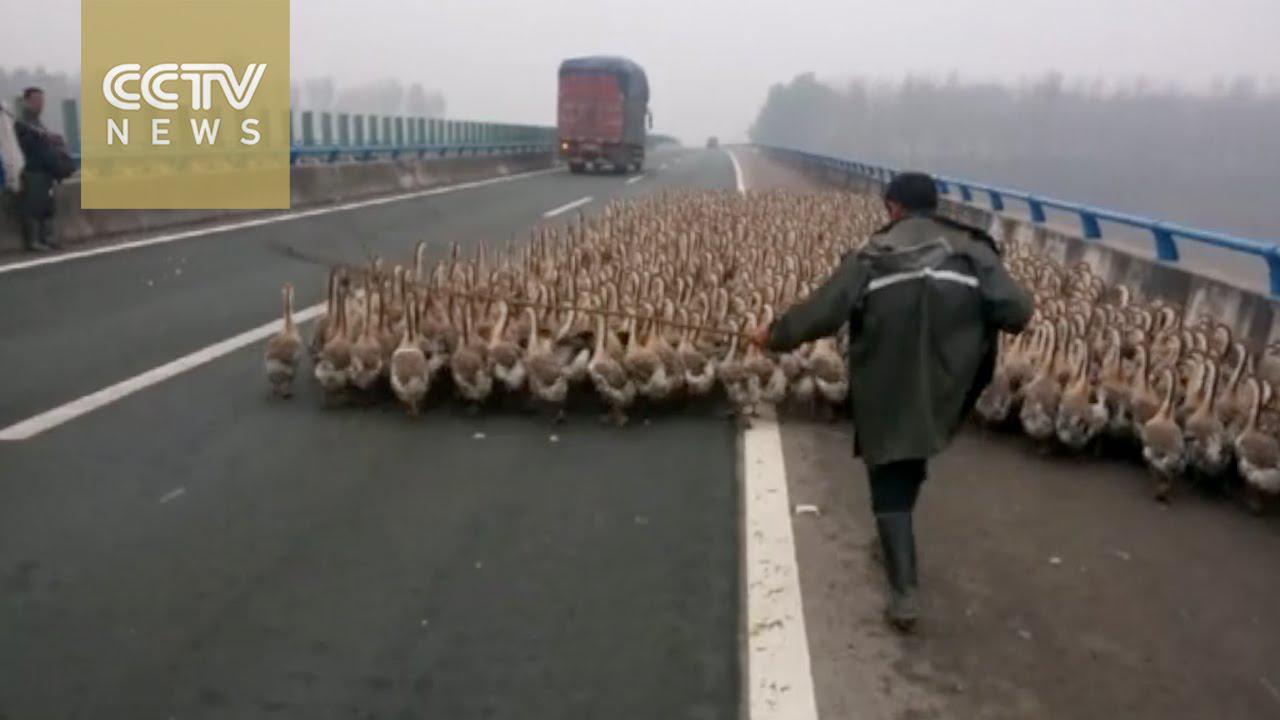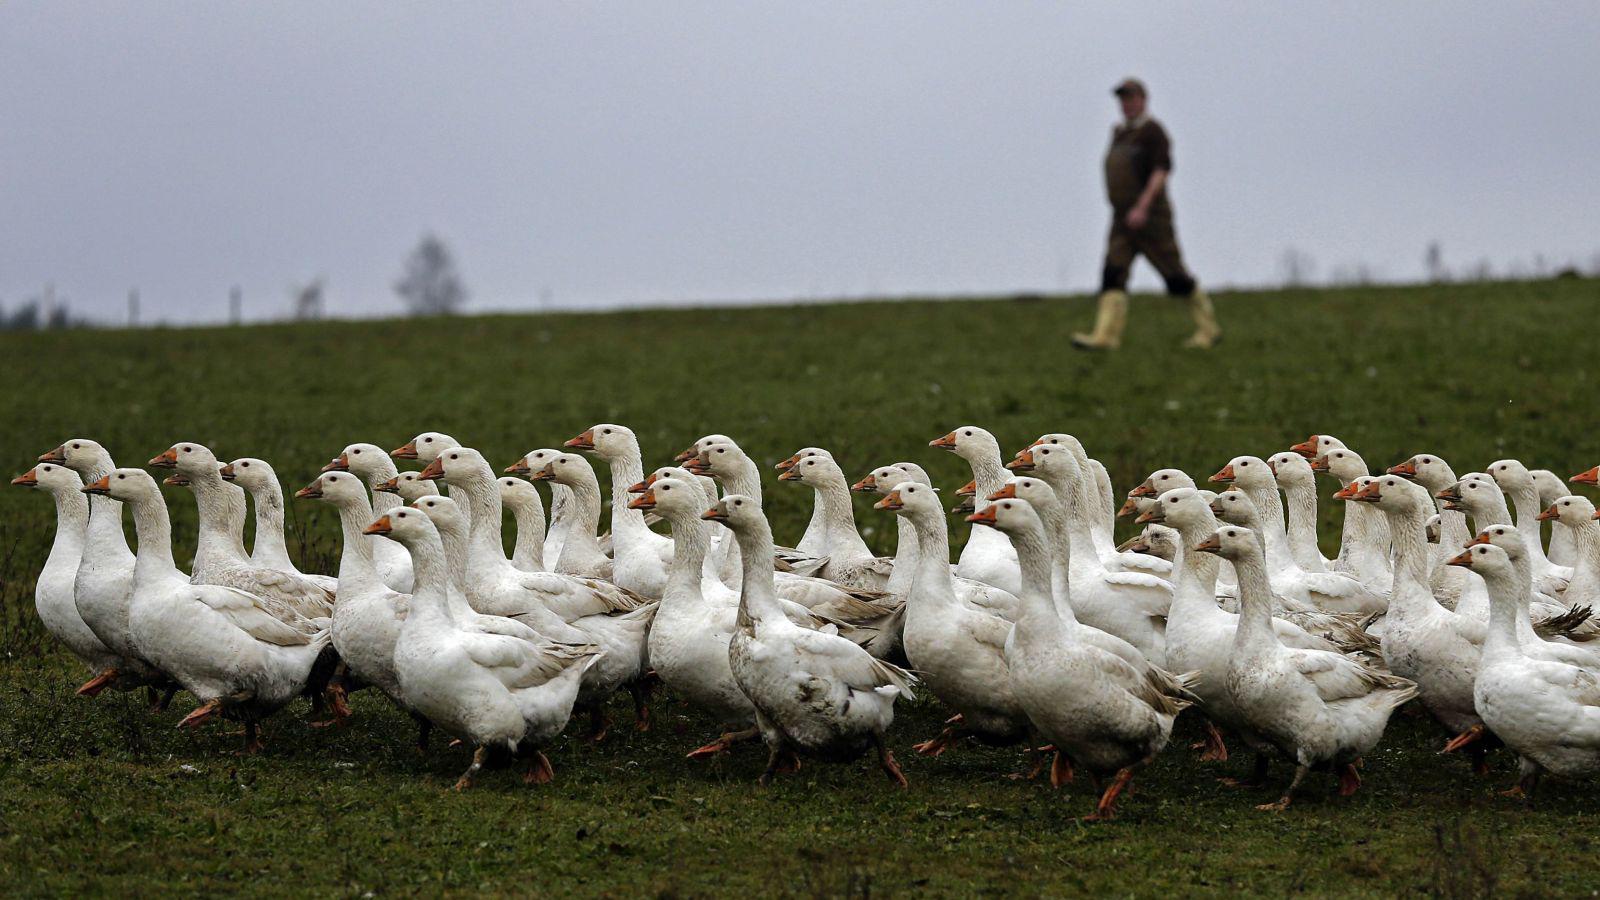The first image is the image on the left, the second image is the image on the right. For the images displayed, is the sentence "Neither of the images of geese contains a human standing on the ground." factually correct? Answer yes or no. No. 